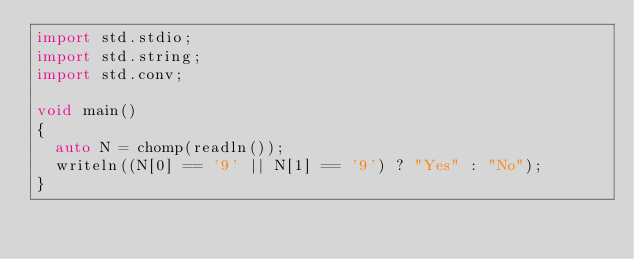Convert code to text. <code><loc_0><loc_0><loc_500><loc_500><_D_>import std.stdio;
import std.string;
import std.conv;

void main()
{
	auto N = chomp(readln());
	writeln((N[0] == '9' || N[1] == '9') ? "Yes" : "No");
}</code> 